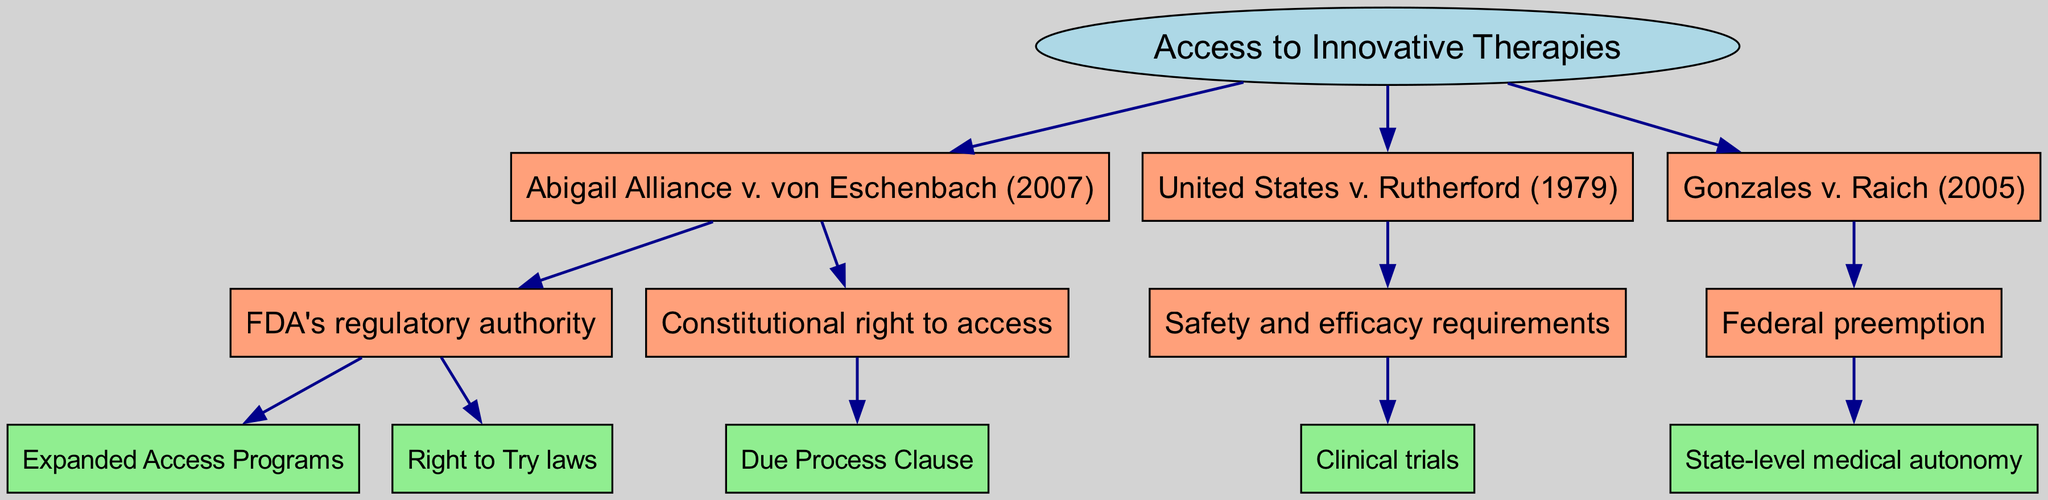What is the root of the diagram? The diagram shows "Access to Innovative Therapies" as the root node, established at the top of the structure.
Answer: Access to Innovative Therapies How many branches are there under the root? The root has three branches listed underneath it: "Abigail Alliance v. von Eschenbach (2007)", "United States v. Rutherford (1979)", and "Gonzales v. Raich (2005)".
Answer: 3 What legal case is associated with "Expanded Access Programs"? The legal case associated with "Expanded Access Programs" is "Abigail Alliance v. von Eschenbach (2007)", which is directly linked to this specific child node.
Answer: Abigail Alliance v. von Eschenbach (2007) Which clause is cited as the basis for the constitutional right to access? The "Due Process Clause" is cited as the basis for the constitutional right to access experimental treatments in the diagram, found as a child of constitutional right to access.
Answer: Due Process Clause What concept is represented as a child of the branch "Federal preemption"? The diagram shows "State-level medical autonomy" as the child node related to the "Federal preemption" branch.
Answer: State-level medical autonomy What are the two components under "FDA's regulatory authority"? The two components are "Expanded Access Programs" and "Right to Try laws", both of which fall under the "FDA's regulatory authority".
Answer: Expanded Access Programs, Right to Try laws How is "Safety and efficacy requirements" related to the "United States v. Rutherford (1979)" case? "Safety and efficacy requirements" is a direct child of the "United States v. Rutherford (1979)" case, indicating it is part of the legal findings associated with this case.
Answer: Safety and efficacy requirements Which precedent governs the relationship between federal authorities and state medical practices? The precedent governing this relationship is "Gonzales v. Raich (2005)", which addresses the conflict between federal laws and state-level decisions in medical practice.
Answer: Gonzales v. Raich (2005) What is the total number of child nodes under the branch related to "Abigail Alliance v. von Eschenbach (2007)"? There are three child nodes under "Abigail Alliance v. von Eschenbach (2007)": "FDA's regulatory authority", "Constitutional right to access", and the sub-nodes under each of them. Counting each child node gives a total of three direct children.
Answer: 3 